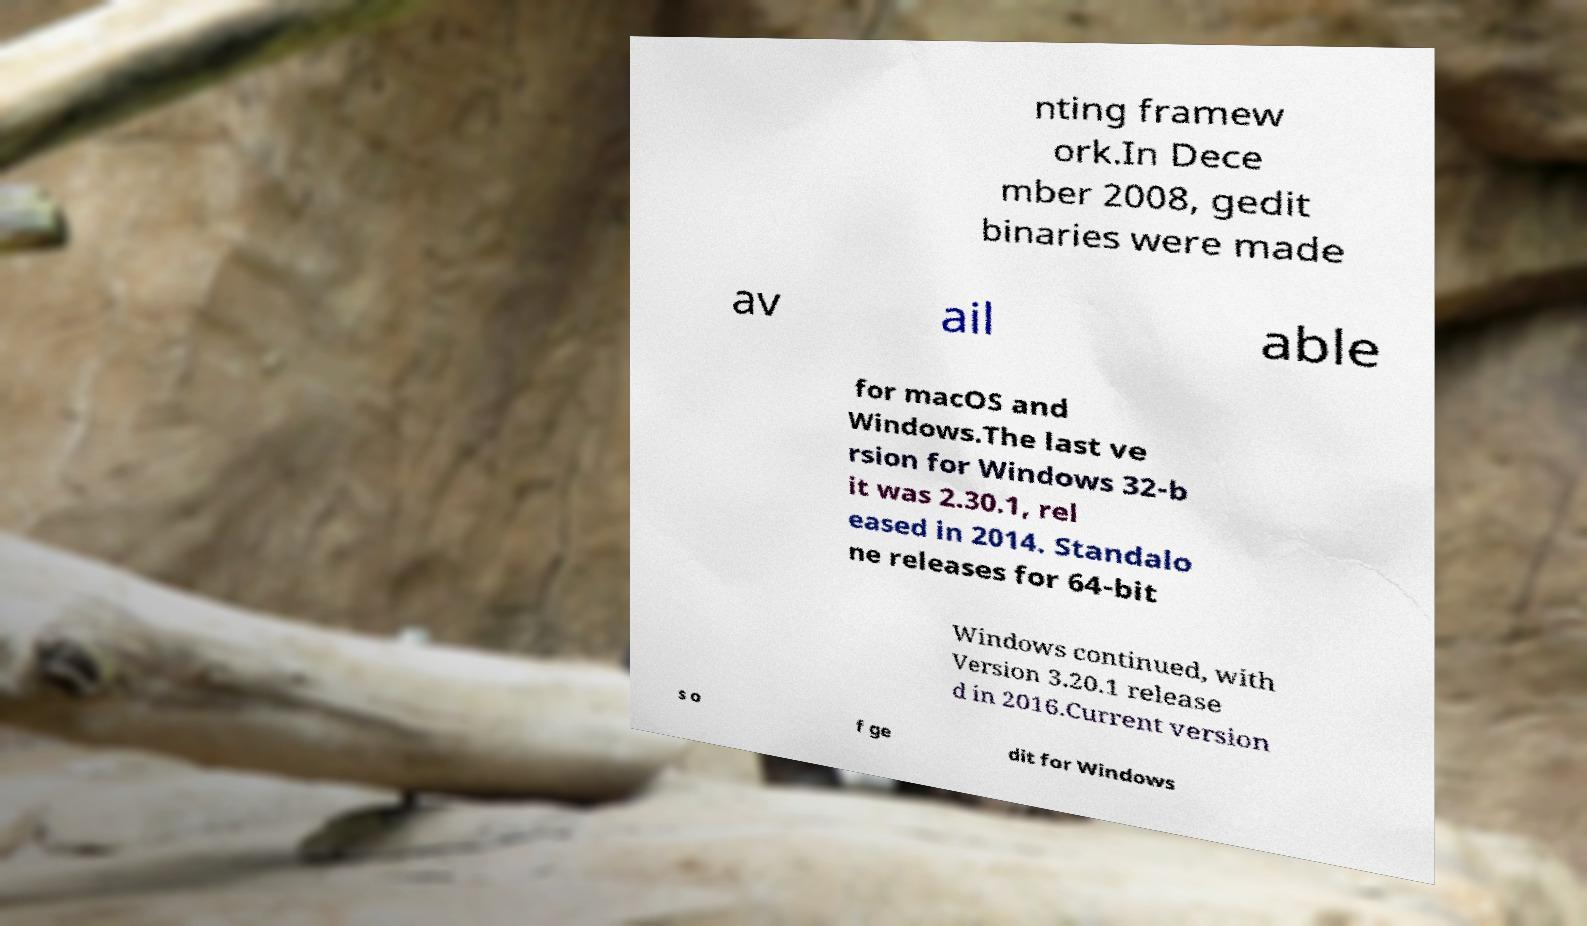Please read and relay the text visible in this image. What does it say? nting framew ork.In Dece mber 2008, gedit binaries were made av ail able for macOS and Windows.The last ve rsion for Windows 32-b it was 2.30.1, rel eased in 2014. Standalo ne releases for 64-bit Windows continued, with Version 3.20.1 release d in 2016.Current version s o f ge dit for Windows 